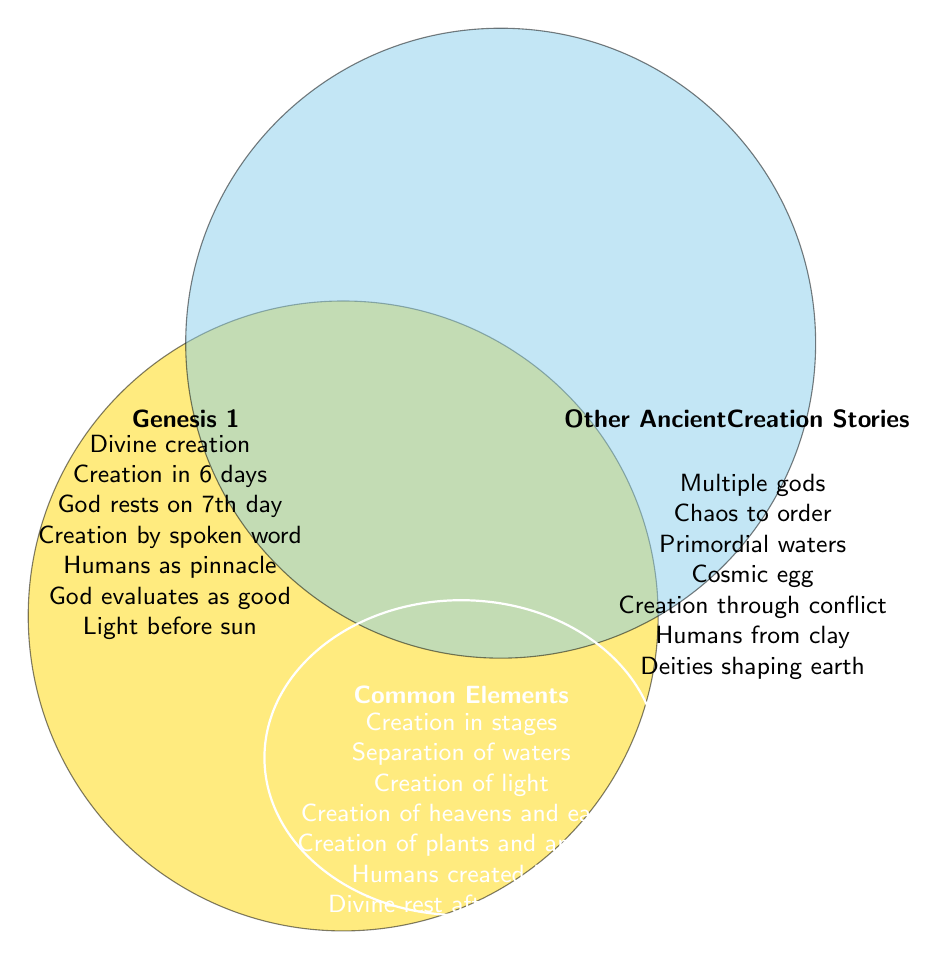What are some elements unique to Genesis 1? Look at the left circle marked "Genesis 1" for elements only found in Genesis 1. These elements include "Divine creation," "Creation in 6 days," "God rests on 7th day," "Creation by spoken word," "Humans as pinnacle," "God evaluates as good," and "Light before sun."
Answer: Seven elements What are some elements unique to other ancient creation stories? Look at the right circle marked "Other Ancient Creation Stories" for elements only found there. These include "Multiple gods," "Chaos to order," "Primordial waters," "Cosmic egg," "Creation through conflict," "Humans from clay," and "Deities shaping earth."
Answer: Seven elements What are the common elements in Genesis 1 and other ancient creation stories? Look at the overlapping section of the Venn diagram labeled "Common Elements." This section includes "Creation in stages," "Separation of waters," "Creation of light," "Creation of heavens and earth," "Creation of plants and animals," "Humans created last," and "Divine rest after creation."
Answer: Seven elements How many elements are unique to Genesis 1? Count the number of elements listed in the left circle labeled "Genesis 1." There are seven unique elements: "Divine creation," "Creation in 6 days," "God rests on 7th day," "Creation by spoken word," "Humans as pinnacle," "God evaluates as good," and "Light before sun."
Answer: Seven elements How many elements are unique to other ancient creation stories? Count the number of elements listed in the right circle labeled "Other Ancient Creation Stories." There are seven unique elements: "Multiple gods," "Chaos to order," "Primordial waters," "Cosmic egg," "Creation through conflict," "Humans from clay," and "Deities shaping earth."
Answer: Seven elements How many total unique elements are there (not common elements)? Add the number of unique elements in Genesis 1 and the unique elements in other creation stories. There are seven unique elements in each, so 7 + 7 = 14 unique elements.
Answer: Fourteen elements Which elements discuss human creation? Identify elements related to human creation in Genesis 1 and other ancient creation stories, as well as in the common elements. These are "Humans as pinnacle" (Genesis 1), "Humans from clay" (Other Ancient Creation Stories), and "Humans created last" (Common Elements).
Answer: Three elements How many elements in total are mentioned in the Venn diagram, including shared and unique? Add the number of unique elements in Genesis 1, the unique elements in other creation stories, and the common elements. There are 7 in Genesis 1, 7 in other stories, and 7 common elements. Therefore, 7 + 7 + 7 = 21 elements in total.
Answer: Twenty-one elements Are there more common elements or unique elements in either Genesis 1 or other ancient creation stories? Compare the number of elements listed as common (7) with the number of unique elements in Genesis 1 (7) and other ancient creation stories (7). The counts are equal, with each category having 7 elements.
Answer: No, they are equal Which unique element of Genesis 1 suggests a sequential creation over a specific number of days? Identify elements in Genesis 1 related to the creation timeline. "Creation in 6 days" specifically suggests a sequential creation over days.
Answer: Creation in 6 days 